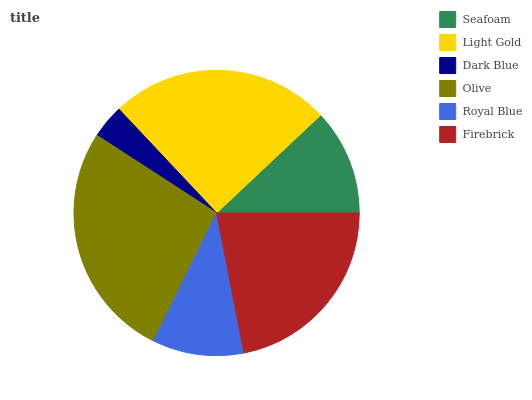Is Dark Blue the minimum?
Answer yes or no. Yes. Is Olive the maximum?
Answer yes or no. Yes. Is Light Gold the minimum?
Answer yes or no. No. Is Light Gold the maximum?
Answer yes or no. No. Is Light Gold greater than Seafoam?
Answer yes or no. Yes. Is Seafoam less than Light Gold?
Answer yes or no. Yes. Is Seafoam greater than Light Gold?
Answer yes or no. No. Is Light Gold less than Seafoam?
Answer yes or no. No. Is Firebrick the high median?
Answer yes or no. Yes. Is Seafoam the low median?
Answer yes or no. Yes. Is Light Gold the high median?
Answer yes or no. No. Is Light Gold the low median?
Answer yes or no. No. 